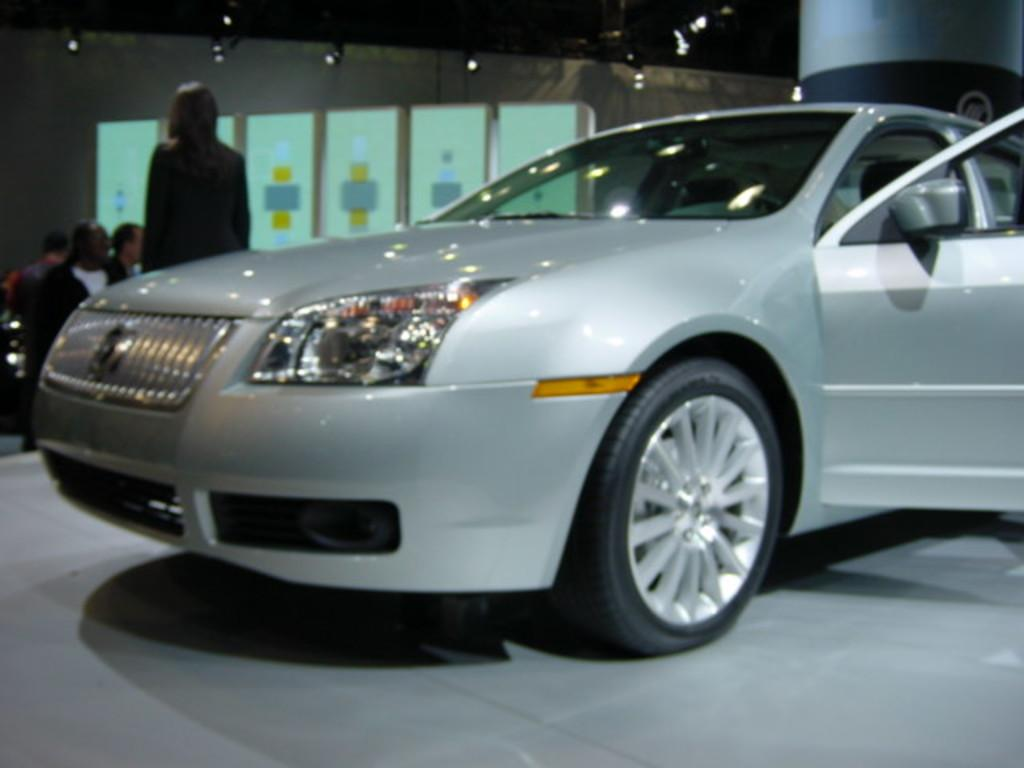What is the main subject of the image? There is a car in the image. What else can be seen in the background of the image? There is a group of people in the background of the image. Can you describe the positions of the people in the group? Some people in the group are seated, and a woman is standing in the group. What can be seen in addition to the car and the group of people? There are lights visible in the image. What reason does the woman in the group give for hating the car in the image? There is no indication in the image that the woman hates the car, nor is there any dialogue or context provided to suggest a reason for her feelings towards the car. 